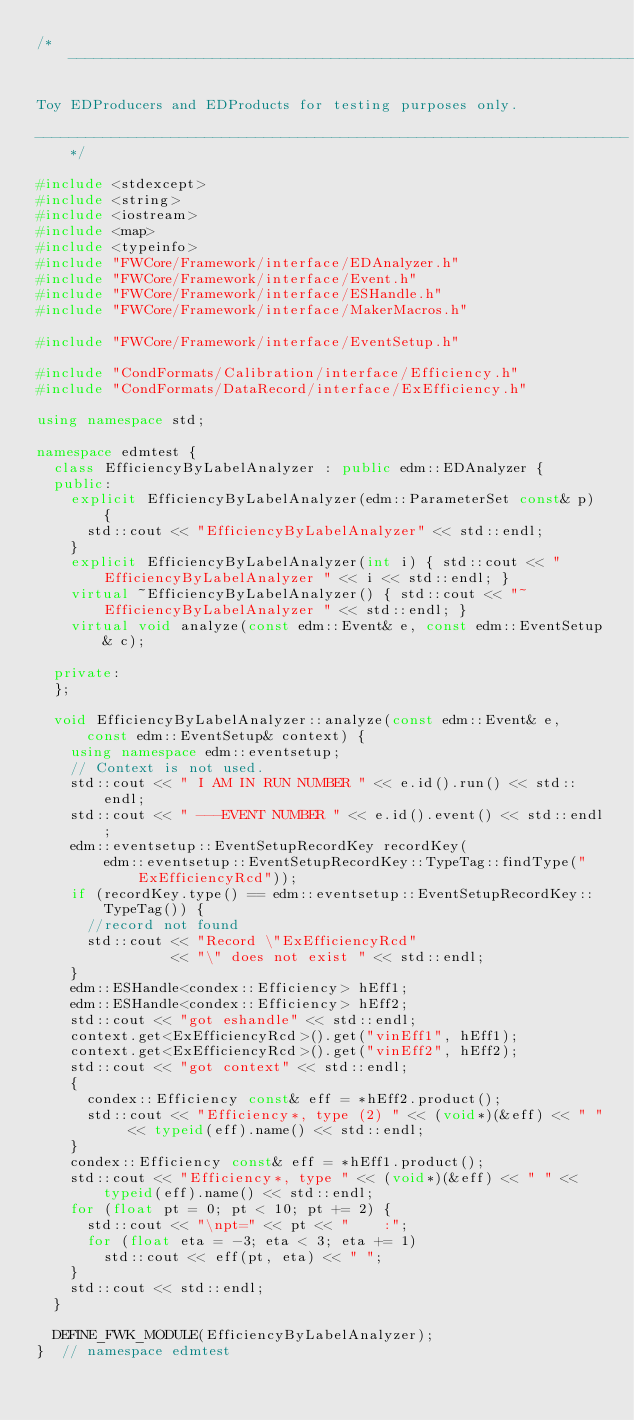<code> <loc_0><loc_0><loc_500><loc_500><_C++_>/*----------------------------------------------------------------------

Toy EDProducers and EDProducts for testing purposes only.

----------------------------------------------------------------------*/

#include <stdexcept>
#include <string>
#include <iostream>
#include <map>
#include <typeinfo>
#include "FWCore/Framework/interface/EDAnalyzer.h"
#include "FWCore/Framework/interface/Event.h"
#include "FWCore/Framework/interface/ESHandle.h"
#include "FWCore/Framework/interface/MakerMacros.h"

#include "FWCore/Framework/interface/EventSetup.h"

#include "CondFormats/Calibration/interface/Efficiency.h"
#include "CondFormats/DataRecord/interface/ExEfficiency.h"

using namespace std;

namespace edmtest {
  class EfficiencyByLabelAnalyzer : public edm::EDAnalyzer {
  public:
    explicit EfficiencyByLabelAnalyzer(edm::ParameterSet const& p) {
      std::cout << "EfficiencyByLabelAnalyzer" << std::endl;
    }
    explicit EfficiencyByLabelAnalyzer(int i) { std::cout << "EfficiencyByLabelAnalyzer " << i << std::endl; }
    virtual ~EfficiencyByLabelAnalyzer() { std::cout << "~EfficiencyByLabelAnalyzer " << std::endl; }
    virtual void analyze(const edm::Event& e, const edm::EventSetup& c);

  private:
  };

  void EfficiencyByLabelAnalyzer::analyze(const edm::Event& e, const edm::EventSetup& context) {
    using namespace edm::eventsetup;
    // Context is not used.
    std::cout << " I AM IN RUN NUMBER " << e.id().run() << std::endl;
    std::cout << " ---EVENT NUMBER " << e.id().event() << std::endl;
    edm::eventsetup::EventSetupRecordKey recordKey(
        edm::eventsetup::EventSetupRecordKey::TypeTag::findType("ExEfficiencyRcd"));
    if (recordKey.type() == edm::eventsetup::EventSetupRecordKey::TypeTag()) {
      //record not found
      std::cout << "Record \"ExEfficiencyRcd"
                << "\" does not exist " << std::endl;
    }
    edm::ESHandle<condex::Efficiency> hEff1;
    edm::ESHandle<condex::Efficiency> hEff2;
    std::cout << "got eshandle" << std::endl;
    context.get<ExEfficiencyRcd>().get("vinEff1", hEff1);
    context.get<ExEfficiencyRcd>().get("vinEff2", hEff2);
    std::cout << "got context" << std::endl;
    {
      condex::Efficiency const& eff = *hEff2.product();
      std::cout << "Efficiency*, type (2) " << (void*)(&eff) << " " << typeid(eff).name() << std::endl;
    }
    condex::Efficiency const& eff = *hEff1.product();
    std::cout << "Efficiency*, type " << (void*)(&eff) << " " << typeid(eff).name() << std::endl;
    for (float pt = 0; pt < 10; pt += 2) {
      std::cout << "\npt=" << pt << "    :";
      for (float eta = -3; eta < 3; eta += 1)
        std::cout << eff(pt, eta) << " ";
    }
    std::cout << std::endl;
  }

  DEFINE_FWK_MODULE(EfficiencyByLabelAnalyzer);
}  // namespace edmtest
</code> 